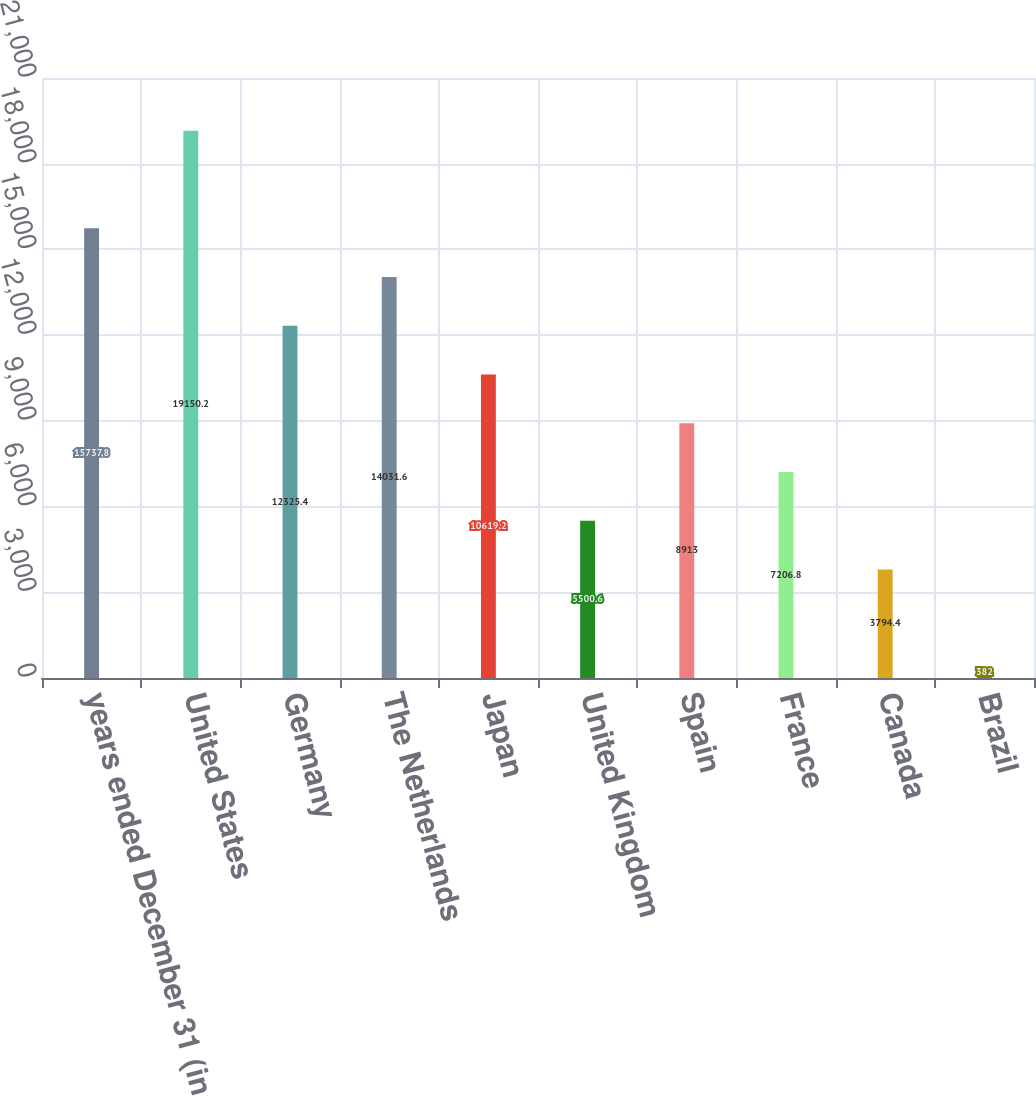Convert chart. <chart><loc_0><loc_0><loc_500><loc_500><bar_chart><fcel>years ended December 31 (in<fcel>United States<fcel>Germany<fcel>The Netherlands<fcel>Japan<fcel>United Kingdom<fcel>Spain<fcel>France<fcel>Canada<fcel>Brazil<nl><fcel>15737.8<fcel>19150.2<fcel>12325.4<fcel>14031.6<fcel>10619.2<fcel>5500.6<fcel>8913<fcel>7206.8<fcel>3794.4<fcel>382<nl></chart> 